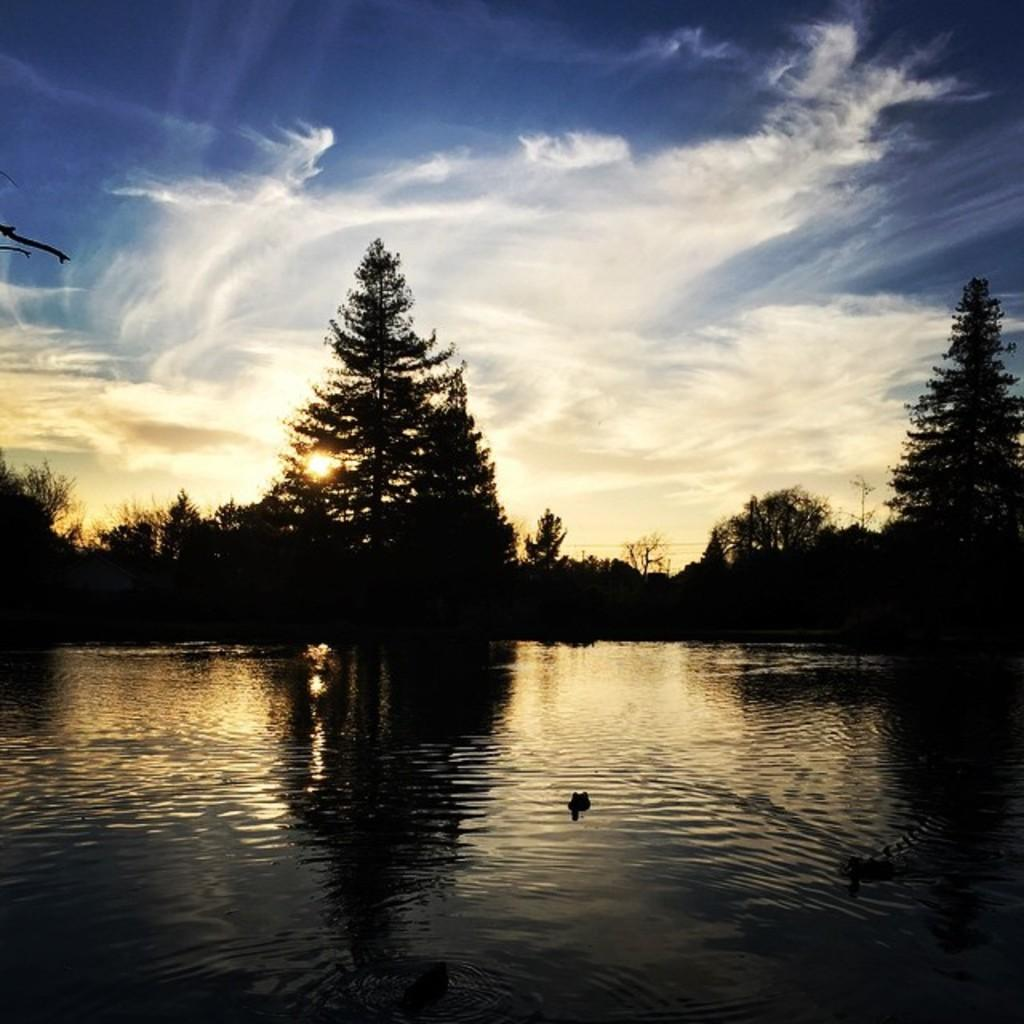What is visible in the image? Water is visible in the image. What type of vegetation can be seen in the image? There are trees in the image. What part of the natural environment is visible in the image? The sky is visible in the background of the image. What type of paint is being used by the lawyer in the image? There is no lawyer or paint present in the image. What type of crack is visible on the tree in the image? There is no crack visible on the tree in the image. 